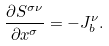Convert formula to latex. <formula><loc_0><loc_0><loc_500><loc_500>\frac { \partial S ^ { \sigma \nu } } { \partial x ^ { \sigma } } = - J ^ { \nu } _ { b } .</formula> 